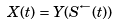<formula> <loc_0><loc_0><loc_500><loc_500>X ( t ) = Y ( S ^ { \leftarrow } ( t ) )</formula> 